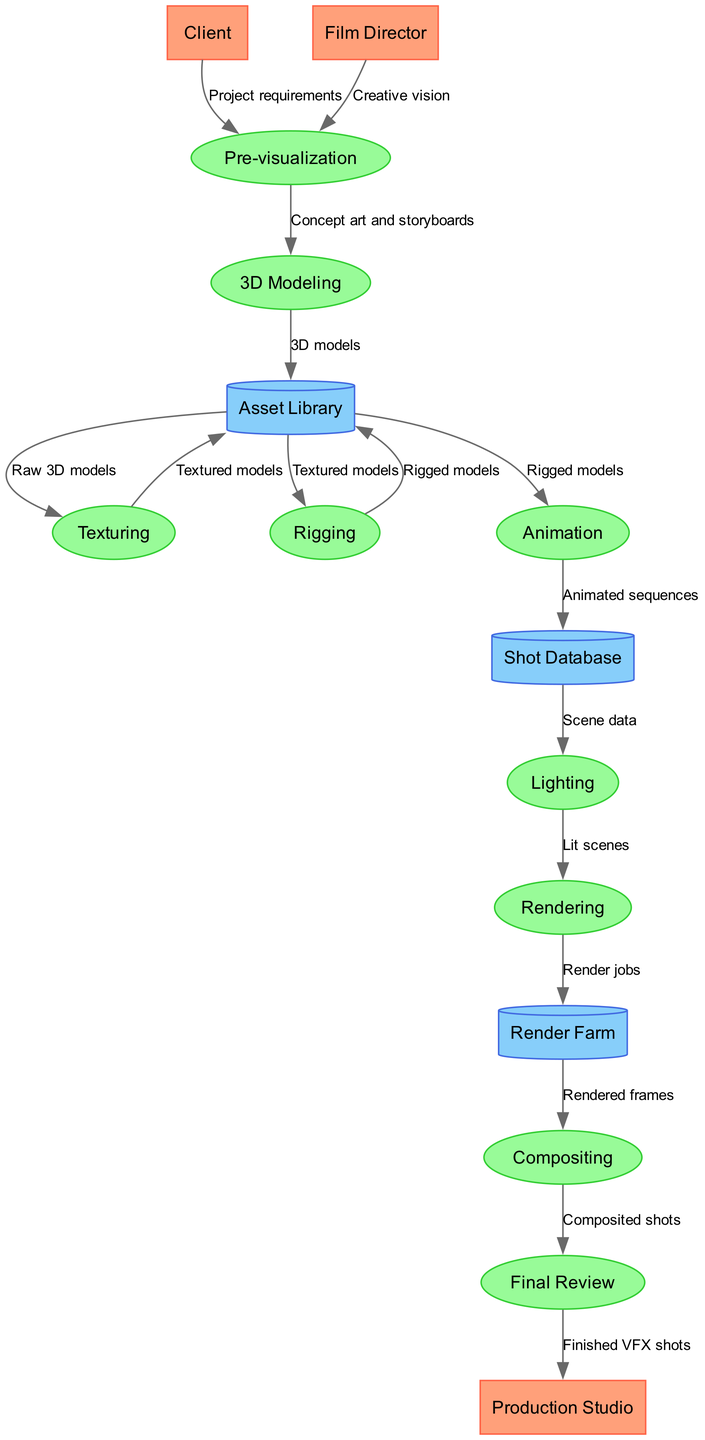What are the external entities in the diagram? The external entities listed in the diagram are "Client", "Film Director", and "Production Studio". They represent the sources that provide input into the visual effects pipeline.
Answer: Client, Film Director, Production Studio How many processes are involved in the VFX pipeline? There are nine distinct processes that the visual effects pipeline goes through, namely: Pre-visualization, 3D Modeling, Texturing, Rigging, Animation, Lighting, Rendering, Compositing, and Final Review.
Answer: Nine What data flow comes from Animation? The data flow that comes from Animation goes to the Shot Database and is labeled as "Animated sequences". This indicates that the animation process outputs data to be stored in the Shot Database.
Answer: Animated sequences Which process follows Lighting in the VFX pipeline? The process that follows Lighting is Rendering. After the lighting work is completed on the scenes, the next step is to render those scenes.
Answer: Rendering What does the Final Review send to the Production Studio? The Final Review sends "Finished VFX shots" to the Production Studio as the output of the visual effects pipeline, indicating that this is the final deliverable to the client.
Answer: Finished VFX shots What type of storage is used for 3D models after Modeling? 3D models created during the Modeling process are stored in the Asset Library. It serves as a repository for various assets used throughout the pipeline.
Answer: Asset Library How many data stores are there in the diagram? The diagram contains three data stores: Asset Library, Shot Database, and Render Farm. These stores are essential for managing and organizing data during the visual effects production.
Answer: Three Which process inputs from the Asset Library alongside Rigging? Animation also inputs from the Asset Library, receiving "Rigged models" alongside the input that Rigging sends after modifying the models.
Answer: Animation What precedes Compositing in the data flow? The process that precedes Compositing in the data flow is Rendering. It takes the rendered frames and composites them to create the final shots.
Answer: Rendering 